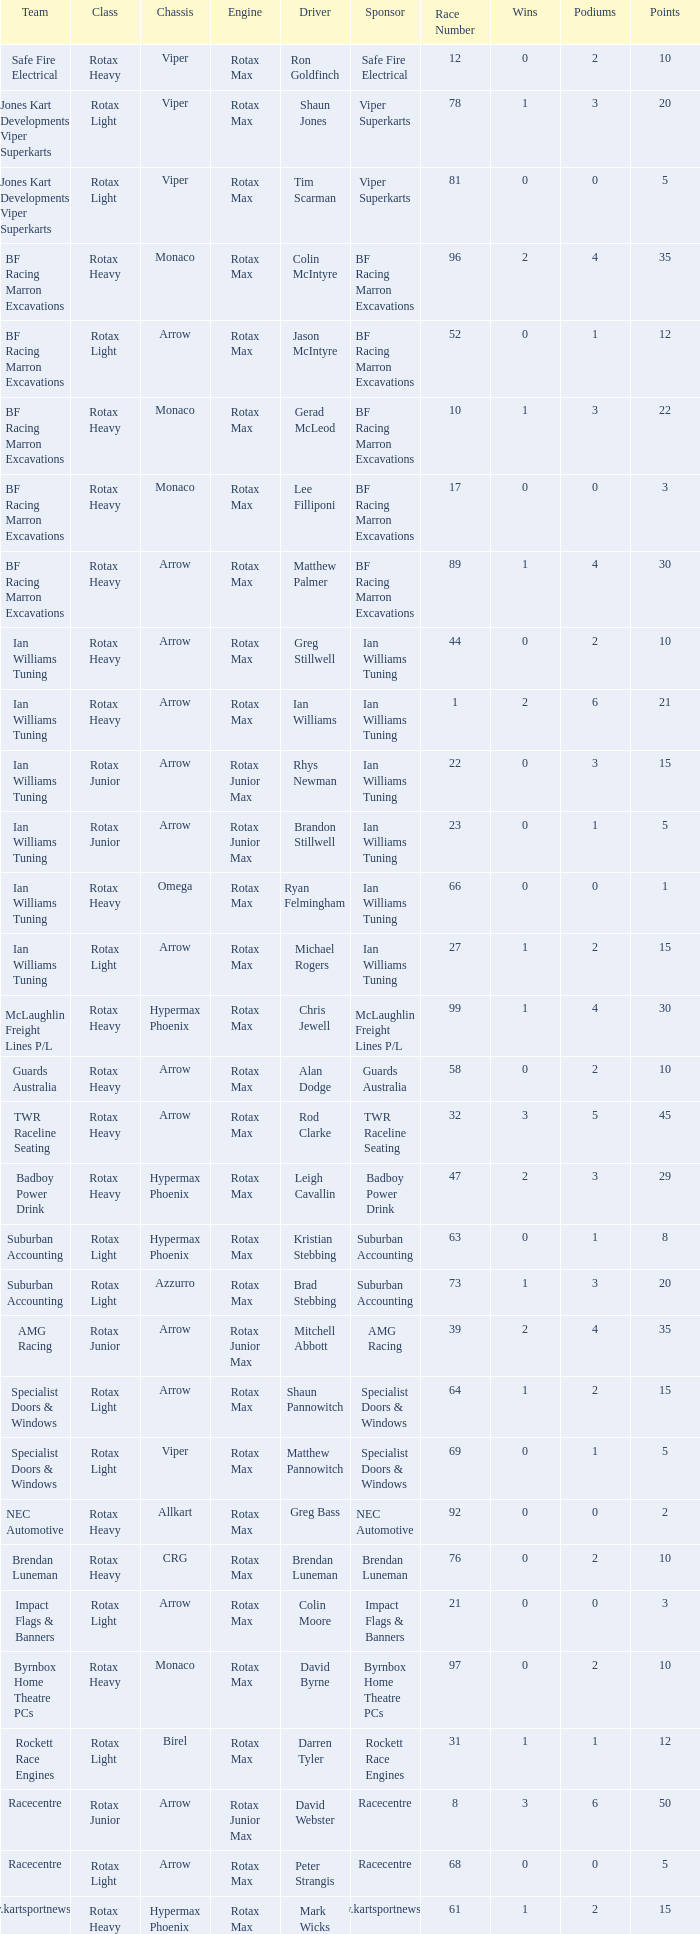Parse the table in full. {'header': ['Team', 'Class', 'Chassis', 'Engine', 'Driver', 'Sponsor', 'Race Number', 'Wins', 'Podiums', 'Points'], 'rows': [['Safe Fire Electrical', 'Rotax Heavy', 'Viper', 'Rotax Max', 'Ron Goldfinch', 'Safe Fire Electrical', '12', '0', '2', '10'], ['Jones Kart Developments Viper Superkarts', 'Rotax Light', 'Viper', 'Rotax Max', 'Shaun Jones', 'Viper Superkarts', '78', '1', '3', '20'], ['Jones Kart Developments Viper Superkarts', 'Rotax Light', 'Viper', 'Rotax Max', 'Tim Scarman', 'Viper Superkarts', '81', '0', '0', '5'], ['BF Racing Marron Excavations', 'Rotax Heavy', 'Monaco', 'Rotax Max', 'Colin McIntyre', 'BF Racing Marron Excavations', '96', '2', '4', '35'], ['BF Racing Marron Excavations', 'Rotax Light', 'Arrow', 'Rotax Max', 'Jason McIntyre', 'BF Racing Marron Excavations', '52', '0', '1', '12'], ['BF Racing Marron Excavations', 'Rotax Heavy', 'Monaco', 'Rotax Max', 'Gerad McLeod', 'BF Racing Marron Excavations', '10', '1', '3', '22'], ['BF Racing Marron Excavations', 'Rotax Heavy', 'Monaco', 'Rotax Max', 'Lee Filliponi', 'BF Racing Marron Excavations', '17', '0', '0', '3'], ['BF Racing Marron Excavations', 'Rotax Heavy', 'Arrow', 'Rotax Max', 'Matthew Palmer', 'BF Racing Marron Excavations', '89', '1', '4', '30'], ['Ian Williams Tuning', 'Rotax Heavy', 'Arrow', 'Rotax Max', 'Greg Stillwell', 'Ian Williams Tuning', '44', '0', '2', '10'], ['Ian Williams Tuning', 'Rotax Heavy', 'Arrow', 'Rotax Max', 'Ian Williams', 'Ian Williams Tuning', '1', '2', '6', '21'], ['Ian Williams Tuning', 'Rotax Junior', 'Arrow', 'Rotax Junior Max', 'Rhys Newman', 'Ian Williams Tuning', '22', '0', '3', '15'], ['Ian Williams Tuning', 'Rotax Junior', 'Arrow', 'Rotax Junior Max', 'Brandon Stillwell', 'Ian Williams Tuning', '23', '0', '1', '5'], ['Ian Williams Tuning', 'Rotax Heavy', 'Omega', 'Rotax Max', 'Ryan Felmingham', 'Ian Williams Tuning', '66', '0', '0', '1'], ['Ian Williams Tuning', 'Rotax Light', 'Arrow', 'Rotax Max', 'Michael Rogers', 'Ian Williams Tuning', '27', '1', '2', '15'], ['McLaughlin Freight Lines P/L', 'Rotax Heavy', 'Hypermax Phoenix', 'Rotax Max', 'Chris Jewell', 'McLaughlin Freight Lines P/L', '99', '1', '4', '30'], ['Guards Australia', 'Rotax Heavy', 'Arrow', 'Rotax Max', 'Alan Dodge', 'Guards Australia', '58', '0', '2', '10'], ['TWR Raceline Seating', 'Rotax Heavy', 'Arrow', 'Rotax Max', 'Rod Clarke', 'TWR Raceline Seating', '32', '3', '5', '45'], ['Badboy Power Drink', 'Rotax Heavy', 'Hypermax Phoenix', 'Rotax Max', 'Leigh Cavallin', 'Badboy Power Drink', '47', '2', '3', '29'], ['Suburban Accounting', 'Rotax Light', 'Hypermax Phoenix', 'Rotax Max', 'Kristian Stebbing', 'Suburban Accounting', '63', '0', '1', '8'], ['Suburban Accounting', 'Rotax Light', 'Azzurro', 'Rotax Max', 'Brad Stebbing', 'Suburban Accounting', '73', '1', '3', '20'], ['AMG Racing', 'Rotax Junior', 'Arrow', 'Rotax Junior Max', 'Mitchell Abbott', 'AMG Racing', '39', '2', '4', '35'], ['Specialist Doors & Windows', 'Rotax Light', 'Arrow', 'Rotax Max', 'Shaun Pannowitch', 'Specialist Doors & Windows', '64', '1', '2', '15'], ['Specialist Doors & Windows', 'Rotax Light', 'Viper', 'Rotax Max', 'Matthew Pannowitch', 'Specialist Doors & Windows', '69', '0', '1', '5'], ['NEC Automotive', 'Rotax Heavy', 'Allkart', 'Rotax Max', 'Greg Bass', 'NEC Automotive', '92', '0', '0', '2'], ['Brendan Luneman', 'Rotax Heavy', 'CRG', 'Rotax Max', 'Brendan Luneman', 'Brendan Luneman', '76', '0', '2', '10'], ['Impact Flags & Banners', 'Rotax Light', 'Arrow', 'Rotax Max', 'Colin Moore', 'Impact Flags & Banners', '21', '0', '0', '3'], ['Byrnbox Home Theatre PCs', 'Rotax Heavy', 'Monaco', 'Rotax Max', 'David Byrne', 'Byrnbox Home Theatre PCs', '97', '0', '2', '10'], ['Rockett Race Engines', 'Rotax Light', 'Birel', 'Rotax Max', 'Darren Tyler', 'Rockett Race Engines', '31', '1', '1', '12'], ['Racecentre', 'Rotax Junior', 'Arrow', 'Rotax Junior Max', 'David Webster', 'Racecentre', '8', '3', '6', '50'], ['Racecentre', 'Rotax Light', 'Arrow', 'Rotax Max', 'Peter Strangis', 'Racecentre', '68', '0', '0', '5'], ['www.kartsportnews.com', 'Rotax Heavy', 'Hypermax Phoenix', 'Rotax Max', 'Mark Wicks', 'www.kartsportnews.com', '61', '1', '2', '15'], ['Doug Savage', 'Rotax Light', 'Arrow', 'Rotax Max', 'Doug Savage', 'Doug Savage', '14', '0', '1', '8'], ['Race Stickerz Toyota Material Handling', 'Rotax Heavy', 'Techno', 'Rotax Max', 'Scott Appledore', 'Race Stickerz Toyota Material Handling', '25', '0', '0', '3'], ['Wild Digital', 'Rotax Junior', 'Hypermax Phoenix', 'Rotax Junior Max', 'Sean Whitfield', 'Wild Digital', '16', '0', '3', '20'], ['John Bartlett', 'Rotax Heavy', 'Hypermax Phoenix', 'Rotax Max', 'John Bartlett', 'John Bartlett', '18', '1', '2', '15']]} What type of engine does the BF Racing Marron Excavations have that also has Monaco as chassis and Lee Filliponi as the driver? Rotax Max. 